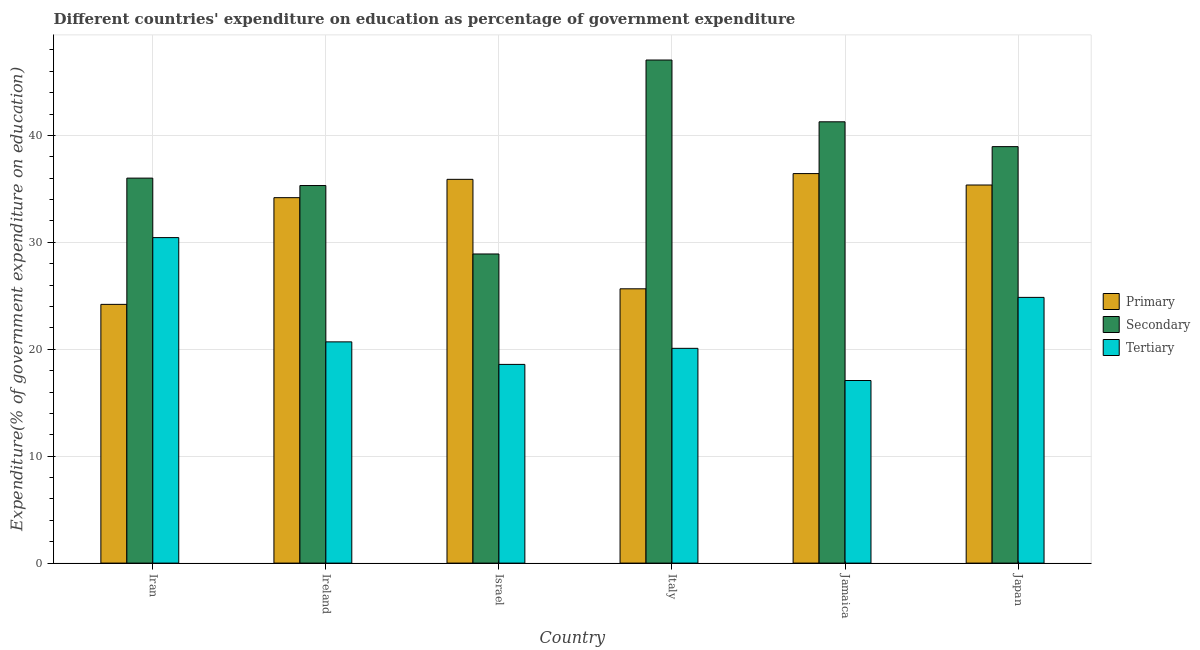How many different coloured bars are there?
Provide a short and direct response. 3. How many groups of bars are there?
Provide a short and direct response. 6. Are the number of bars per tick equal to the number of legend labels?
Ensure brevity in your answer.  Yes. Are the number of bars on each tick of the X-axis equal?
Your answer should be very brief. Yes. How many bars are there on the 2nd tick from the right?
Offer a very short reply. 3. What is the label of the 2nd group of bars from the left?
Your answer should be very brief. Ireland. In how many cases, is the number of bars for a given country not equal to the number of legend labels?
Provide a succinct answer. 0. What is the expenditure on primary education in Jamaica?
Make the answer very short. 36.43. Across all countries, what is the maximum expenditure on tertiary education?
Offer a terse response. 30.44. Across all countries, what is the minimum expenditure on secondary education?
Offer a very short reply. 28.91. In which country was the expenditure on tertiary education maximum?
Your answer should be compact. Iran. In which country was the expenditure on secondary education minimum?
Offer a terse response. Israel. What is the total expenditure on secondary education in the graph?
Provide a succinct answer. 227.51. What is the difference between the expenditure on primary education in Israel and that in Italy?
Your answer should be very brief. 10.24. What is the difference between the expenditure on primary education in Italy and the expenditure on secondary education in Ireland?
Your response must be concise. -9.66. What is the average expenditure on secondary education per country?
Provide a succinct answer. 37.92. What is the difference between the expenditure on secondary education and expenditure on tertiary education in Ireland?
Your answer should be very brief. 14.62. What is the ratio of the expenditure on secondary education in Italy to that in Jamaica?
Offer a very short reply. 1.14. Is the difference between the expenditure on tertiary education in Ireland and Jamaica greater than the difference between the expenditure on primary education in Ireland and Jamaica?
Keep it short and to the point. Yes. What is the difference between the highest and the second highest expenditure on primary education?
Your answer should be compact. 0.54. What is the difference between the highest and the lowest expenditure on secondary education?
Provide a short and direct response. 18.14. In how many countries, is the expenditure on secondary education greater than the average expenditure on secondary education taken over all countries?
Keep it short and to the point. 3. What does the 2nd bar from the left in Jamaica represents?
Your response must be concise. Secondary. What does the 2nd bar from the right in Israel represents?
Provide a short and direct response. Secondary. Is it the case that in every country, the sum of the expenditure on primary education and expenditure on secondary education is greater than the expenditure on tertiary education?
Provide a succinct answer. Yes. How many bars are there?
Provide a short and direct response. 18. Are all the bars in the graph horizontal?
Offer a terse response. No. How many countries are there in the graph?
Ensure brevity in your answer.  6. What is the difference between two consecutive major ticks on the Y-axis?
Give a very brief answer. 10. Does the graph contain any zero values?
Offer a terse response. No. Does the graph contain grids?
Offer a terse response. Yes. How many legend labels are there?
Offer a very short reply. 3. How are the legend labels stacked?
Keep it short and to the point. Vertical. What is the title of the graph?
Offer a very short reply. Different countries' expenditure on education as percentage of government expenditure. What is the label or title of the Y-axis?
Provide a short and direct response. Expenditure(% of government expenditure on education). What is the Expenditure(% of government expenditure on education) of Primary in Iran?
Your response must be concise. 24.2. What is the Expenditure(% of government expenditure on education) in Secondary in Iran?
Make the answer very short. 36.01. What is the Expenditure(% of government expenditure on education) of Tertiary in Iran?
Keep it short and to the point. 30.44. What is the Expenditure(% of government expenditure on education) in Primary in Ireland?
Offer a very short reply. 34.18. What is the Expenditure(% of government expenditure on education) of Secondary in Ireland?
Your response must be concise. 35.31. What is the Expenditure(% of government expenditure on education) of Tertiary in Ireland?
Offer a terse response. 20.69. What is the Expenditure(% of government expenditure on education) of Primary in Israel?
Ensure brevity in your answer.  35.89. What is the Expenditure(% of government expenditure on education) of Secondary in Israel?
Ensure brevity in your answer.  28.91. What is the Expenditure(% of government expenditure on education) of Tertiary in Israel?
Provide a succinct answer. 18.58. What is the Expenditure(% of government expenditure on education) in Primary in Italy?
Provide a short and direct response. 25.65. What is the Expenditure(% of government expenditure on education) in Secondary in Italy?
Ensure brevity in your answer.  47.05. What is the Expenditure(% of government expenditure on education) of Tertiary in Italy?
Make the answer very short. 20.09. What is the Expenditure(% of government expenditure on education) in Primary in Jamaica?
Give a very brief answer. 36.43. What is the Expenditure(% of government expenditure on education) of Secondary in Jamaica?
Offer a very short reply. 41.27. What is the Expenditure(% of government expenditure on education) of Tertiary in Jamaica?
Make the answer very short. 17.08. What is the Expenditure(% of government expenditure on education) of Primary in Japan?
Your response must be concise. 35.36. What is the Expenditure(% of government expenditure on education) in Secondary in Japan?
Make the answer very short. 38.95. What is the Expenditure(% of government expenditure on education) in Tertiary in Japan?
Offer a very short reply. 24.85. Across all countries, what is the maximum Expenditure(% of government expenditure on education) of Primary?
Ensure brevity in your answer.  36.43. Across all countries, what is the maximum Expenditure(% of government expenditure on education) in Secondary?
Offer a terse response. 47.05. Across all countries, what is the maximum Expenditure(% of government expenditure on education) of Tertiary?
Provide a short and direct response. 30.44. Across all countries, what is the minimum Expenditure(% of government expenditure on education) of Primary?
Provide a succinct answer. 24.2. Across all countries, what is the minimum Expenditure(% of government expenditure on education) of Secondary?
Make the answer very short. 28.91. Across all countries, what is the minimum Expenditure(% of government expenditure on education) in Tertiary?
Make the answer very short. 17.08. What is the total Expenditure(% of government expenditure on education) of Primary in the graph?
Offer a terse response. 191.72. What is the total Expenditure(% of government expenditure on education) in Secondary in the graph?
Offer a very short reply. 227.51. What is the total Expenditure(% of government expenditure on education) of Tertiary in the graph?
Give a very brief answer. 131.74. What is the difference between the Expenditure(% of government expenditure on education) in Primary in Iran and that in Ireland?
Provide a short and direct response. -9.98. What is the difference between the Expenditure(% of government expenditure on education) of Secondary in Iran and that in Ireland?
Offer a terse response. 0.69. What is the difference between the Expenditure(% of government expenditure on education) in Tertiary in Iran and that in Ireland?
Offer a very short reply. 9.75. What is the difference between the Expenditure(% of government expenditure on education) in Primary in Iran and that in Israel?
Offer a very short reply. -11.69. What is the difference between the Expenditure(% of government expenditure on education) of Secondary in Iran and that in Israel?
Your answer should be compact. 7.09. What is the difference between the Expenditure(% of government expenditure on education) in Tertiary in Iran and that in Israel?
Make the answer very short. 11.86. What is the difference between the Expenditure(% of government expenditure on education) in Primary in Iran and that in Italy?
Your answer should be compact. -1.45. What is the difference between the Expenditure(% of government expenditure on education) in Secondary in Iran and that in Italy?
Give a very brief answer. -11.04. What is the difference between the Expenditure(% of government expenditure on education) in Tertiary in Iran and that in Italy?
Your answer should be very brief. 10.36. What is the difference between the Expenditure(% of government expenditure on education) of Primary in Iran and that in Jamaica?
Give a very brief answer. -12.23. What is the difference between the Expenditure(% of government expenditure on education) in Secondary in Iran and that in Jamaica?
Your response must be concise. -5.27. What is the difference between the Expenditure(% of government expenditure on education) of Tertiary in Iran and that in Jamaica?
Your response must be concise. 13.37. What is the difference between the Expenditure(% of government expenditure on education) in Primary in Iran and that in Japan?
Your response must be concise. -11.16. What is the difference between the Expenditure(% of government expenditure on education) of Secondary in Iran and that in Japan?
Your response must be concise. -2.94. What is the difference between the Expenditure(% of government expenditure on education) in Tertiary in Iran and that in Japan?
Offer a terse response. 5.59. What is the difference between the Expenditure(% of government expenditure on education) of Primary in Ireland and that in Israel?
Keep it short and to the point. -1.72. What is the difference between the Expenditure(% of government expenditure on education) of Secondary in Ireland and that in Israel?
Your answer should be very brief. 6.4. What is the difference between the Expenditure(% of government expenditure on education) of Tertiary in Ireland and that in Israel?
Your answer should be compact. 2.11. What is the difference between the Expenditure(% of government expenditure on education) in Primary in Ireland and that in Italy?
Offer a very short reply. 8.52. What is the difference between the Expenditure(% of government expenditure on education) in Secondary in Ireland and that in Italy?
Your response must be concise. -11.74. What is the difference between the Expenditure(% of government expenditure on education) in Tertiary in Ireland and that in Italy?
Provide a short and direct response. 0.6. What is the difference between the Expenditure(% of government expenditure on education) of Primary in Ireland and that in Jamaica?
Give a very brief answer. -2.25. What is the difference between the Expenditure(% of government expenditure on education) of Secondary in Ireland and that in Jamaica?
Your answer should be very brief. -5.96. What is the difference between the Expenditure(% of government expenditure on education) of Tertiary in Ireland and that in Jamaica?
Offer a very short reply. 3.61. What is the difference between the Expenditure(% of government expenditure on education) of Primary in Ireland and that in Japan?
Provide a short and direct response. -1.18. What is the difference between the Expenditure(% of government expenditure on education) in Secondary in Ireland and that in Japan?
Offer a terse response. -3.64. What is the difference between the Expenditure(% of government expenditure on education) in Tertiary in Ireland and that in Japan?
Make the answer very short. -4.16. What is the difference between the Expenditure(% of government expenditure on education) of Primary in Israel and that in Italy?
Ensure brevity in your answer.  10.24. What is the difference between the Expenditure(% of government expenditure on education) of Secondary in Israel and that in Italy?
Offer a very short reply. -18.14. What is the difference between the Expenditure(% of government expenditure on education) of Tertiary in Israel and that in Italy?
Provide a succinct answer. -1.5. What is the difference between the Expenditure(% of government expenditure on education) in Primary in Israel and that in Jamaica?
Keep it short and to the point. -0.54. What is the difference between the Expenditure(% of government expenditure on education) of Secondary in Israel and that in Jamaica?
Make the answer very short. -12.36. What is the difference between the Expenditure(% of government expenditure on education) in Tertiary in Israel and that in Jamaica?
Keep it short and to the point. 1.51. What is the difference between the Expenditure(% of government expenditure on education) of Primary in Israel and that in Japan?
Your answer should be very brief. 0.53. What is the difference between the Expenditure(% of government expenditure on education) of Secondary in Israel and that in Japan?
Your answer should be very brief. -10.04. What is the difference between the Expenditure(% of government expenditure on education) in Tertiary in Israel and that in Japan?
Offer a terse response. -6.27. What is the difference between the Expenditure(% of government expenditure on education) of Primary in Italy and that in Jamaica?
Your answer should be compact. -10.78. What is the difference between the Expenditure(% of government expenditure on education) of Secondary in Italy and that in Jamaica?
Offer a very short reply. 5.78. What is the difference between the Expenditure(% of government expenditure on education) of Tertiary in Italy and that in Jamaica?
Give a very brief answer. 3.01. What is the difference between the Expenditure(% of government expenditure on education) in Primary in Italy and that in Japan?
Provide a succinct answer. -9.71. What is the difference between the Expenditure(% of government expenditure on education) of Secondary in Italy and that in Japan?
Keep it short and to the point. 8.1. What is the difference between the Expenditure(% of government expenditure on education) in Tertiary in Italy and that in Japan?
Offer a terse response. -4.77. What is the difference between the Expenditure(% of government expenditure on education) in Primary in Jamaica and that in Japan?
Provide a succinct answer. 1.07. What is the difference between the Expenditure(% of government expenditure on education) in Secondary in Jamaica and that in Japan?
Keep it short and to the point. 2.32. What is the difference between the Expenditure(% of government expenditure on education) of Tertiary in Jamaica and that in Japan?
Offer a very short reply. -7.78. What is the difference between the Expenditure(% of government expenditure on education) in Primary in Iran and the Expenditure(% of government expenditure on education) in Secondary in Ireland?
Ensure brevity in your answer.  -11.11. What is the difference between the Expenditure(% of government expenditure on education) in Primary in Iran and the Expenditure(% of government expenditure on education) in Tertiary in Ireland?
Your response must be concise. 3.51. What is the difference between the Expenditure(% of government expenditure on education) of Secondary in Iran and the Expenditure(% of government expenditure on education) of Tertiary in Ireland?
Your response must be concise. 15.32. What is the difference between the Expenditure(% of government expenditure on education) in Primary in Iran and the Expenditure(% of government expenditure on education) in Secondary in Israel?
Make the answer very short. -4.71. What is the difference between the Expenditure(% of government expenditure on education) of Primary in Iran and the Expenditure(% of government expenditure on education) of Tertiary in Israel?
Offer a terse response. 5.61. What is the difference between the Expenditure(% of government expenditure on education) in Secondary in Iran and the Expenditure(% of government expenditure on education) in Tertiary in Israel?
Give a very brief answer. 17.42. What is the difference between the Expenditure(% of government expenditure on education) of Primary in Iran and the Expenditure(% of government expenditure on education) of Secondary in Italy?
Ensure brevity in your answer.  -22.85. What is the difference between the Expenditure(% of government expenditure on education) in Primary in Iran and the Expenditure(% of government expenditure on education) in Tertiary in Italy?
Your answer should be compact. 4.11. What is the difference between the Expenditure(% of government expenditure on education) in Secondary in Iran and the Expenditure(% of government expenditure on education) in Tertiary in Italy?
Make the answer very short. 15.92. What is the difference between the Expenditure(% of government expenditure on education) in Primary in Iran and the Expenditure(% of government expenditure on education) in Secondary in Jamaica?
Offer a very short reply. -17.07. What is the difference between the Expenditure(% of government expenditure on education) of Primary in Iran and the Expenditure(% of government expenditure on education) of Tertiary in Jamaica?
Provide a short and direct response. 7.12. What is the difference between the Expenditure(% of government expenditure on education) in Secondary in Iran and the Expenditure(% of government expenditure on education) in Tertiary in Jamaica?
Your response must be concise. 18.93. What is the difference between the Expenditure(% of government expenditure on education) in Primary in Iran and the Expenditure(% of government expenditure on education) in Secondary in Japan?
Make the answer very short. -14.75. What is the difference between the Expenditure(% of government expenditure on education) of Primary in Iran and the Expenditure(% of government expenditure on education) of Tertiary in Japan?
Your answer should be very brief. -0.65. What is the difference between the Expenditure(% of government expenditure on education) of Secondary in Iran and the Expenditure(% of government expenditure on education) of Tertiary in Japan?
Your answer should be very brief. 11.15. What is the difference between the Expenditure(% of government expenditure on education) of Primary in Ireland and the Expenditure(% of government expenditure on education) of Secondary in Israel?
Provide a succinct answer. 5.27. What is the difference between the Expenditure(% of government expenditure on education) in Primary in Ireland and the Expenditure(% of government expenditure on education) in Tertiary in Israel?
Make the answer very short. 15.59. What is the difference between the Expenditure(% of government expenditure on education) in Secondary in Ireland and the Expenditure(% of government expenditure on education) in Tertiary in Israel?
Your answer should be very brief. 16.73. What is the difference between the Expenditure(% of government expenditure on education) in Primary in Ireland and the Expenditure(% of government expenditure on education) in Secondary in Italy?
Provide a short and direct response. -12.87. What is the difference between the Expenditure(% of government expenditure on education) of Primary in Ireland and the Expenditure(% of government expenditure on education) of Tertiary in Italy?
Your answer should be compact. 14.09. What is the difference between the Expenditure(% of government expenditure on education) of Secondary in Ireland and the Expenditure(% of government expenditure on education) of Tertiary in Italy?
Your answer should be very brief. 15.23. What is the difference between the Expenditure(% of government expenditure on education) in Primary in Ireland and the Expenditure(% of government expenditure on education) in Secondary in Jamaica?
Provide a succinct answer. -7.1. What is the difference between the Expenditure(% of government expenditure on education) in Primary in Ireland and the Expenditure(% of government expenditure on education) in Tertiary in Jamaica?
Keep it short and to the point. 17.1. What is the difference between the Expenditure(% of government expenditure on education) in Secondary in Ireland and the Expenditure(% of government expenditure on education) in Tertiary in Jamaica?
Your answer should be very brief. 18.24. What is the difference between the Expenditure(% of government expenditure on education) in Primary in Ireland and the Expenditure(% of government expenditure on education) in Secondary in Japan?
Your answer should be compact. -4.77. What is the difference between the Expenditure(% of government expenditure on education) of Primary in Ireland and the Expenditure(% of government expenditure on education) of Tertiary in Japan?
Keep it short and to the point. 9.33. What is the difference between the Expenditure(% of government expenditure on education) of Secondary in Ireland and the Expenditure(% of government expenditure on education) of Tertiary in Japan?
Give a very brief answer. 10.46. What is the difference between the Expenditure(% of government expenditure on education) of Primary in Israel and the Expenditure(% of government expenditure on education) of Secondary in Italy?
Make the answer very short. -11.16. What is the difference between the Expenditure(% of government expenditure on education) in Primary in Israel and the Expenditure(% of government expenditure on education) in Tertiary in Italy?
Your response must be concise. 15.81. What is the difference between the Expenditure(% of government expenditure on education) of Secondary in Israel and the Expenditure(% of government expenditure on education) of Tertiary in Italy?
Keep it short and to the point. 8.83. What is the difference between the Expenditure(% of government expenditure on education) of Primary in Israel and the Expenditure(% of government expenditure on education) of Secondary in Jamaica?
Your answer should be very brief. -5.38. What is the difference between the Expenditure(% of government expenditure on education) of Primary in Israel and the Expenditure(% of government expenditure on education) of Tertiary in Jamaica?
Keep it short and to the point. 18.82. What is the difference between the Expenditure(% of government expenditure on education) of Secondary in Israel and the Expenditure(% of government expenditure on education) of Tertiary in Jamaica?
Make the answer very short. 11.84. What is the difference between the Expenditure(% of government expenditure on education) in Primary in Israel and the Expenditure(% of government expenditure on education) in Secondary in Japan?
Keep it short and to the point. -3.06. What is the difference between the Expenditure(% of government expenditure on education) in Primary in Israel and the Expenditure(% of government expenditure on education) in Tertiary in Japan?
Your answer should be very brief. 11.04. What is the difference between the Expenditure(% of government expenditure on education) of Secondary in Israel and the Expenditure(% of government expenditure on education) of Tertiary in Japan?
Your response must be concise. 4.06. What is the difference between the Expenditure(% of government expenditure on education) of Primary in Italy and the Expenditure(% of government expenditure on education) of Secondary in Jamaica?
Provide a short and direct response. -15.62. What is the difference between the Expenditure(% of government expenditure on education) of Primary in Italy and the Expenditure(% of government expenditure on education) of Tertiary in Jamaica?
Your response must be concise. 8.58. What is the difference between the Expenditure(% of government expenditure on education) in Secondary in Italy and the Expenditure(% of government expenditure on education) in Tertiary in Jamaica?
Your answer should be compact. 29.97. What is the difference between the Expenditure(% of government expenditure on education) of Primary in Italy and the Expenditure(% of government expenditure on education) of Secondary in Japan?
Keep it short and to the point. -13.3. What is the difference between the Expenditure(% of government expenditure on education) in Primary in Italy and the Expenditure(% of government expenditure on education) in Tertiary in Japan?
Your response must be concise. 0.8. What is the difference between the Expenditure(% of government expenditure on education) of Secondary in Italy and the Expenditure(% of government expenditure on education) of Tertiary in Japan?
Make the answer very short. 22.2. What is the difference between the Expenditure(% of government expenditure on education) in Primary in Jamaica and the Expenditure(% of government expenditure on education) in Secondary in Japan?
Offer a very short reply. -2.52. What is the difference between the Expenditure(% of government expenditure on education) of Primary in Jamaica and the Expenditure(% of government expenditure on education) of Tertiary in Japan?
Your answer should be compact. 11.58. What is the difference between the Expenditure(% of government expenditure on education) in Secondary in Jamaica and the Expenditure(% of government expenditure on education) in Tertiary in Japan?
Provide a short and direct response. 16.42. What is the average Expenditure(% of government expenditure on education) of Primary per country?
Ensure brevity in your answer.  31.95. What is the average Expenditure(% of government expenditure on education) in Secondary per country?
Your response must be concise. 37.92. What is the average Expenditure(% of government expenditure on education) in Tertiary per country?
Keep it short and to the point. 21.96. What is the difference between the Expenditure(% of government expenditure on education) of Primary and Expenditure(% of government expenditure on education) of Secondary in Iran?
Your answer should be compact. -11.81. What is the difference between the Expenditure(% of government expenditure on education) in Primary and Expenditure(% of government expenditure on education) in Tertiary in Iran?
Give a very brief answer. -6.24. What is the difference between the Expenditure(% of government expenditure on education) in Secondary and Expenditure(% of government expenditure on education) in Tertiary in Iran?
Give a very brief answer. 5.56. What is the difference between the Expenditure(% of government expenditure on education) in Primary and Expenditure(% of government expenditure on education) in Secondary in Ireland?
Offer a terse response. -1.13. What is the difference between the Expenditure(% of government expenditure on education) in Primary and Expenditure(% of government expenditure on education) in Tertiary in Ireland?
Your answer should be very brief. 13.49. What is the difference between the Expenditure(% of government expenditure on education) of Secondary and Expenditure(% of government expenditure on education) of Tertiary in Ireland?
Your answer should be compact. 14.62. What is the difference between the Expenditure(% of government expenditure on education) in Primary and Expenditure(% of government expenditure on education) in Secondary in Israel?
Give a very brief answer. 6.98. What is the difference between the Expenditure(% of government expenditure on education) in Primary and Expenditure(% of government expenditure on education) in Tertiary in Israel?
Provide a succinct answer. 17.31. What is the difference between the Expenditure(% of government expenditure on education) in Secondary and Expenditure(% of government expenditure on education) in Tertiary in Israel?
Provide a succinct answer. 10.33. What is the difference between the Expenditure(% of government expenditure on education) of Primary and Expenditure(% of government expenditure on education) of Secondary in Italy?
Provide a short and direct response. -21.4. What is the difference between the Expenditure(% of government expenditure on education) of Primary and Expenditure(% of government expenditure on education) of Tertiary in Italy?
Your response must be concise. 5.57. What is the difference between the Expenditure(% of government expenditure on education) of Secondary and Expenditure(% of government expenditure on education) of Tertiary in Italy?
Provide a short and direct response. 26.96. What is the difference between the Expenditure(% of government expenditure on education) of Primary and Expenditure(% of government expenditure on education) of Secondary in Jamaica?
Keep it short and to the point. -4.84. What is the difference between the Expenditure(% of government expenditure on education) of Primary and Expenditure(% of government expenditure on education) of Tertiary in Jamaica?
Keep it short and to the point. 19.35. What is the difference between the Expenditure(% of government expenditure on education) in Secondary and Expenditure(% of government expenditure on education) in Tertiary in Jamaica?
Provide a succinct answer. 24.2. What is the difference between the Expenditure(% of government expenditure on education) of Primary and Expenditure(% of government expenditure on education) of Secondary in Japan?
Ensure brevity in your answer.  -3.59. What is the difference between the Expenditure(% of government expenditure on education) of Primary and Expenditure(% of government expenditure on education) of Tertiary in Japan?
Provide a short and direct response. 10.51. What is the difference between the Expenditure(% of government expenditure on education) in Secondary and Expenditure(% of government expenditure on education) in Tertiary in Japan?
Offer a terse response. 14.1. What is the ratio of the Expenditure(% of government expenditure on education) in Primary in Iran to that in Ireland?
Give a very brief answer. 0.71. What is the ratio of the Expenditure(% of government expenditure on education) of Secondary in Iran to that in Ireland?
Keep it short and to the point. 1.02. What is the ratio of the Expenditure(% of government expenditure on education) of Tertiary in Iran to that in Ireland?
Keep it short and to the point. 1.47. What is the ratio of the Expenditure(% of government expenditure on education) in Primary in Iran to that in Israel?
Ensure brevity in your answer.  0.67. What is the ratio of the Expenditure(% of government expenditure on education) of Secondary in Iran to that in Israel?
Your response must be concise. 1.25. What is the ratio of the Expenditure(% of government expenditure on education) of Tertiary in Iran to that in Israel?
Your response must be concise. 1.64. What is the ratio of the Expenditure(% of government expenditure on education) in Primary in Iran to that in Italy?
Your response must be concise. 0.94. What is the ratio of the Expenditure(% of government expenditure on education) of Secondary in Iran to that in Italy?
Make the answer very short. 0.77. What is the ratio of the Expenditure(% of government expenditure on education) in Tertiary in Iran to that in Italy?
Keep it short and to the point. 1.52. What is the ratio of the Expenditure(% of government expenditure on education) in Primary in Iran to that in Jamaica?
Your answer should be very brief. 0.66. What is the ratio of the Expenditure(% of government expenditure on education) of Secondary in Iran to that in Jamaica?
Give a very brief answer. 0.87. What is the ratio of the Expenditure(% of government expenditure on education) in Tertiary in Iran to that in Jamaica?
Keep it short and to the point. 1.78. What is the ratio of the Expenditure(% of government expenditure on education) of Primary in Iran to that in Japan?
Your answer should be very brief. 0.68. What is the ratio of the Expenditure(% of government expenditure on education) in Secondary in Iran to that in Japan?
Your answer should be very brief. 0.92. What is the ratio of the Expenditure(% of government expenditure on education) of Tertiary in Iran to that in Japan?
Provide a succinct answer. 1.23. What is the ratio of the Expenditure(% of government expenditure on education) in Primary in Ireland to that in Israel?
Your answer should be compact. 0.95. What is the ratio of the Expenditure(% of government expenditure on education) of Secondary in Ireland to that in Israel?
Offer a very short reply. 1.22. What is the ratio of the Expenditure(% of government expenditure on education) of Tertiary in Ireland to that in Israel?
Keep it short and to the point. 1.11. What is the ratio of the Expenditure(% of government expenditure on education) in Primary in Ireland to that in Italy?
Your response must be concise. 1.33. What is the ratio of the Expenditure(% of government expenditure on education) in Secondary in Ireland to that in Italy?
Ensure brevity in your answer.  0.75. What is the ratio of the Expenditure(% of government expenditure on education) of Tertiary in Ireland to that in Italy?
Make the answer very short. 1.03. What is the ratio of the Expenditure(% of government expenditure on education) in Primary in Ireland to that in Jamaica?
Keep it short and to the point. 0.94. What is the ratio of the Expenditure(% of government expenditure on education) in Secondary in Ireland to that in Jamaica?
Ensure brevity in your answer.  0.86. What is the ratio of the Expenditure(% of government expenditure on education) of Tertiary in Ireland to that in Jamaica?
Ensure brevity in your answer.  1.21. What is the ratio of the Expenditure(% of government expenditure on education) of Primary in Ireland to that in Japan?
Provide a short and direct response. 0.97. What is the ratio of the Expenditure(% of government expenditure on education) of Secondary in Ireland to that in Japan?
Your answer should be compact. 0.91. What is the ratio of the Expenditure(% of government expenditure on education) of Tertiary in Ireland to that in Japan?
Your answer should be compact. 0.83. What is the ratio of the Expenditure(% of government expenditure on education) in Primary in Israel to that in Italy?
Offer a terse response. 1.4. What is the ratio of the Expenditure(% of government expenditure on education) in Secondary in Israel to that in Italy?
Provide a short and direct response. 0.61. What is the ratio of the Expenditure(% of government expenditure on education) in Tertiary in Israel to that in Italy?
Your answer should be compact. 0.93. What is the ratio of the Expenditure(% of government expenditure on education) of Primary in Israel to that in Jamaica?
Make the answer very short. 0.99. What is the ratio of the Expenditure(% of government expenditure on education) of Secondary in Israel to that in Jamaica?
Offer a very short reply. 0.7. What is the ratio of the Expenditure(% of government expenditure on education) in Tertiary in Israel to that in Jamaica?
Ensure brevity in your answer.  1.09. What is the ratio of the Expenditure(% of government expenditure on education) of Secondary in Israel to that in Japan?
Offer a very short reply. 0.74. What is the ratio of the Expenditure(% of government expenditure on education) of Tertiary in Israel to that in Japan?
Ensure brevity in your answer.  0.75. What is the ratio of the Expenditure(% of government expenditure on education) in Primary in Italy to that in Jamaica?
Ensure brevity in your answer.  0.7. What is the ratio of the Expenditure(% of government expenditure on education) in Secondary in Italy to that in Jamaica?
Ensure brevity in your answer.  1.14. What is the ratio of the Expenditure(% of government expenditure on education) of Tertiary in Italy to that in Jamaica?
Offer a very short reply. 1.18. What is the ratio of the Expenditure(% of government expenditure on education) in Primary in Italy to that in Japan?
Your answer should be compact. 0.73. What is the ratio of the Expenditure(% of government expenditure on education) of Secondary in Italy to that in Japan?
Ensure brevity in your answer.  1.21. What is the ratio of the Expenditure(% of government expenditure on education) in Tertiary in Italy to that in Japan?
Offer a terse response. 0.81. What is the ratio of the Expenditure(% of government expenditure on education) in Primary in Jamaica to that in Japan?
Offer a terse response. 1.03. What is the ratio of the Expenditure(% of government expenditure on education) in Secondary in Jamaica to that in Japan?
Give a very brief answer. 1.06. What is the ratio of the Expenditure(% of government expenditure on education) of Tertiary in Jamaica to that in Japan?
Offer a very short reply. 0.69. What is the difference between the highest and the second highest Expenditure(% of government expenditure on education) in Primary?
Your answer should be compact. 0.54. What is the difference between the highest and the second highest Expenditure(% of government expenditure on education) in Secondary?
Offer a very short reply. 5.78. What is the difference between the highest and the second highest Expenditure(% of government expenditure on education) of Tertiary?
Offer a very short reply. 5.59. What is the difference between the highest and the lowest Expenditure(% of government expenditure on education) in Primary?
Provide a succinct answer. 12.23. What is the difference between the highest and the lowest Expenditure(% of government expenditure on education) in Secondary?
Your answer should be compact. 18.14. What is the difference between the highest and the lowest Expenditure(% of government expenditure on education) of Tertiary?
Offer a terse response. 13.37. 